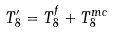<formula> <loc_0><loc_0><loc_500><loc_500>T ^ { \prime } _ { 8 } = T _ { 8 } ^ { f } + T _ { 8 } ^ { m c }</formula> 